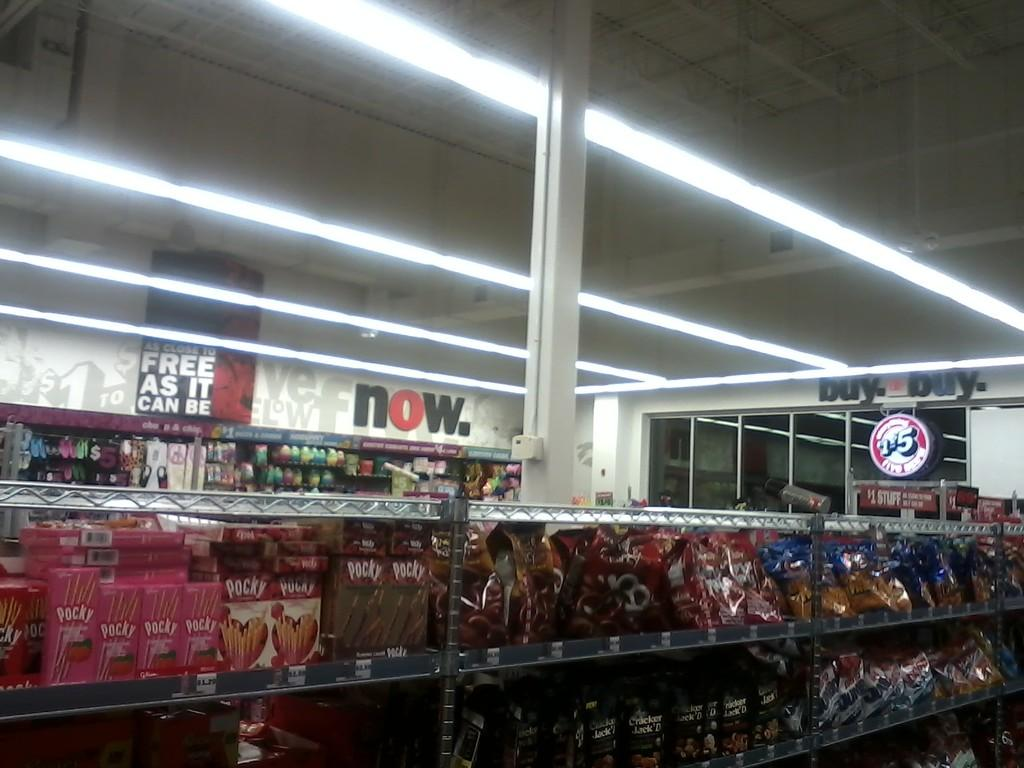<image>
Present a compact description of the photo's key features. Against the back wall, to the right is a sign that reads now. 